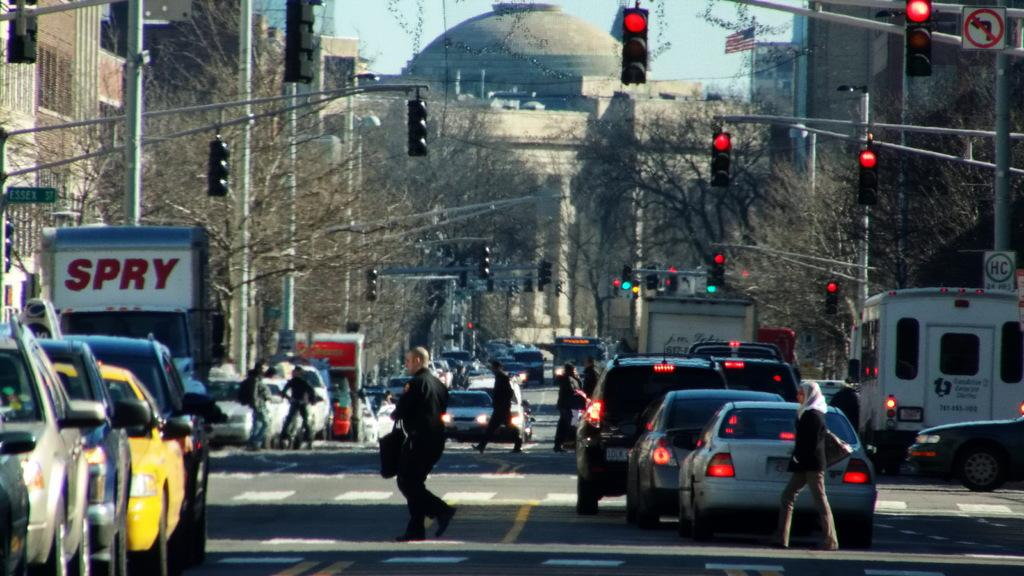<image>
Describe the image concisely. a busy road with stops signs has a truck with letters SPRY on the side 